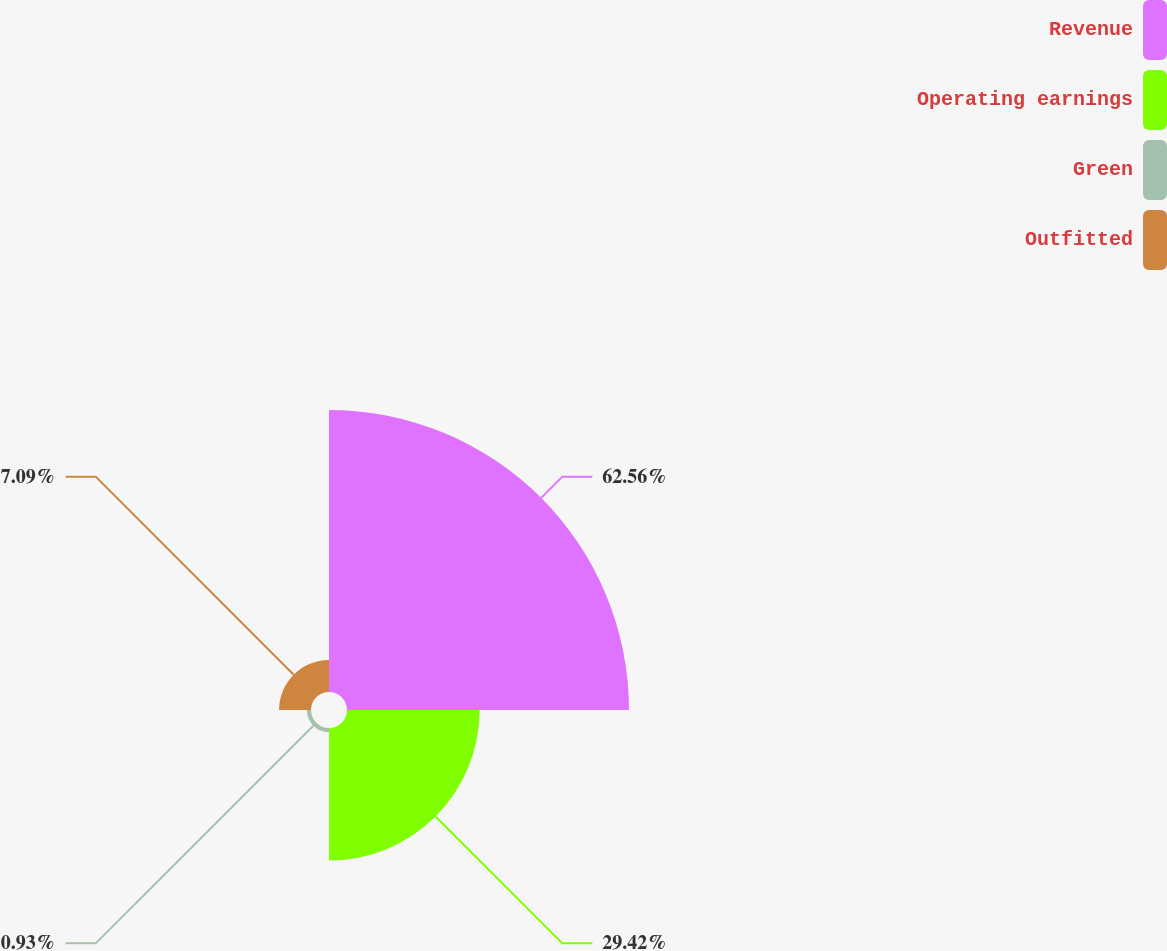<chart> <loc_0><loc_0><loc_500><loc_500><pie_chart><fcel>Revenue<fcel>Operating earnings<fcel>Green<fcel>Outfitted<nl><fcel>62.56%<fcel>29.42%<fcel>0.93%<fcel>7.09%<nl></chart> 